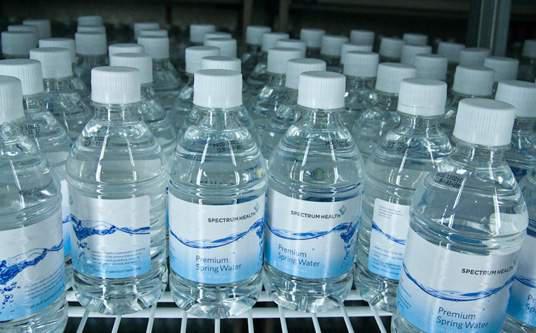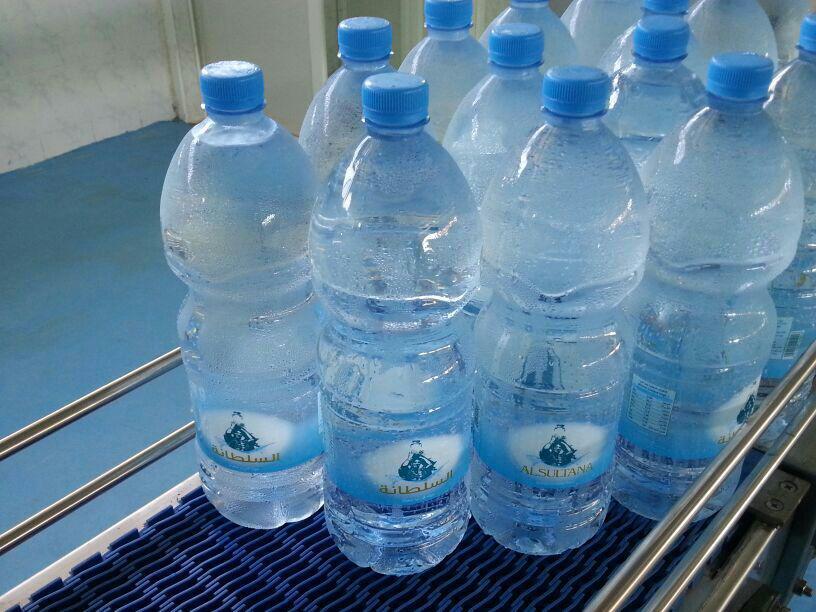The first image is the image on the left, the second image is the image on the right. For the images displayed, is the sentence "Bottles with blue caps are on a blue grated surface." factually correct? Answer yes or no. Yes. The first image is the image on the left, the second image is the image on the right. Given the left and right images, does the statement "an image shows individual, unwrapped bottles with white lids." hold true? Answer yes or no. Yes. 